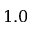<formula> <loc_0><loc_0><loc_500><loc_500>1 . 0</formula> 